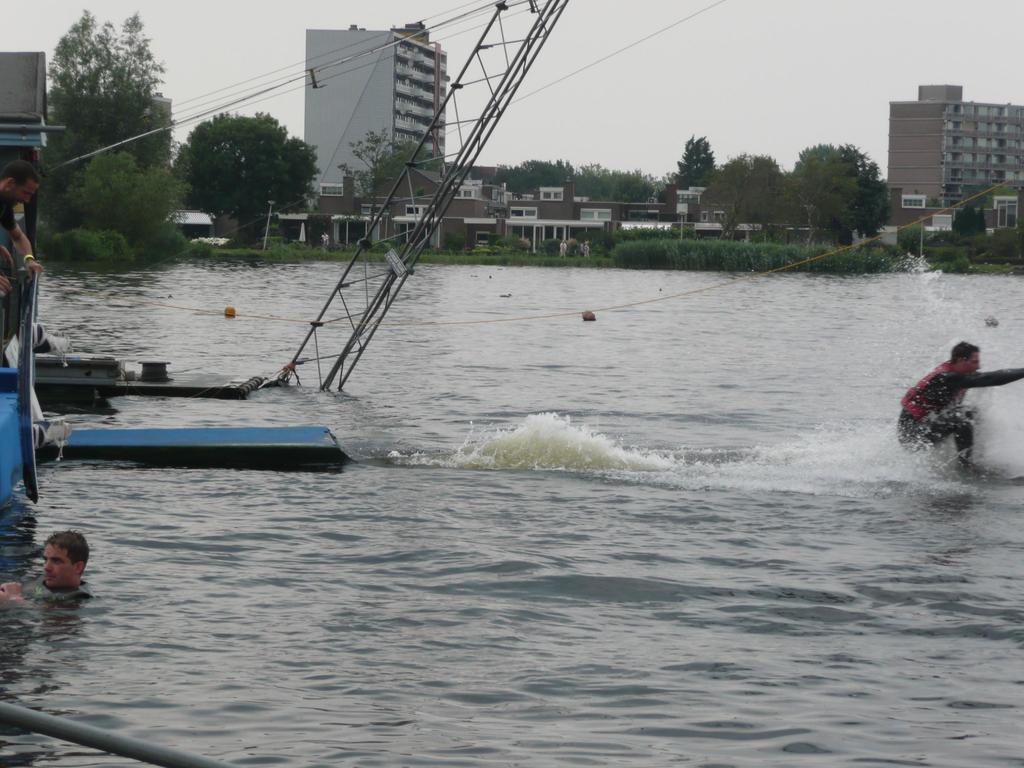What are the people in the image doing? The people in the image are in the water. What can be seen in the background of the image? There are trees, buildings, plants, houses, and the sky visible in the background of the image. Where is the boat located in the image? The boat is on the left side of the image. What type of boot is being used to measure the depth of the water in the image? There is no boot or measuring activity present in the image. What plant is growing on the person in the boat in the image? There are no plants growing on the person in the boat in the image. 